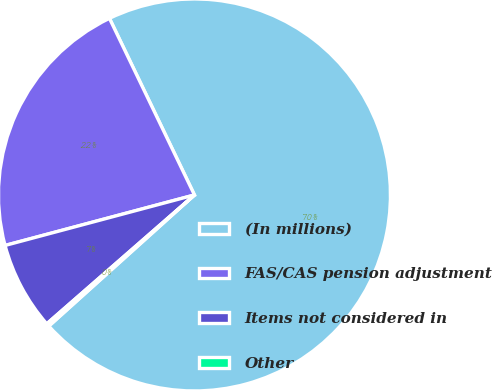Convert chart. <chart><loc_0><loc_0><loc_500><loc_500><pie_chart><fcel>(In millions)<fcel>FAS/CAS pension adjustment<fcel>Items not considered in<fcel>Other<nl><fcel>70.48%<fcel>22.01%<fcel>7.27%<fcel>0.25%<nl></chart> 